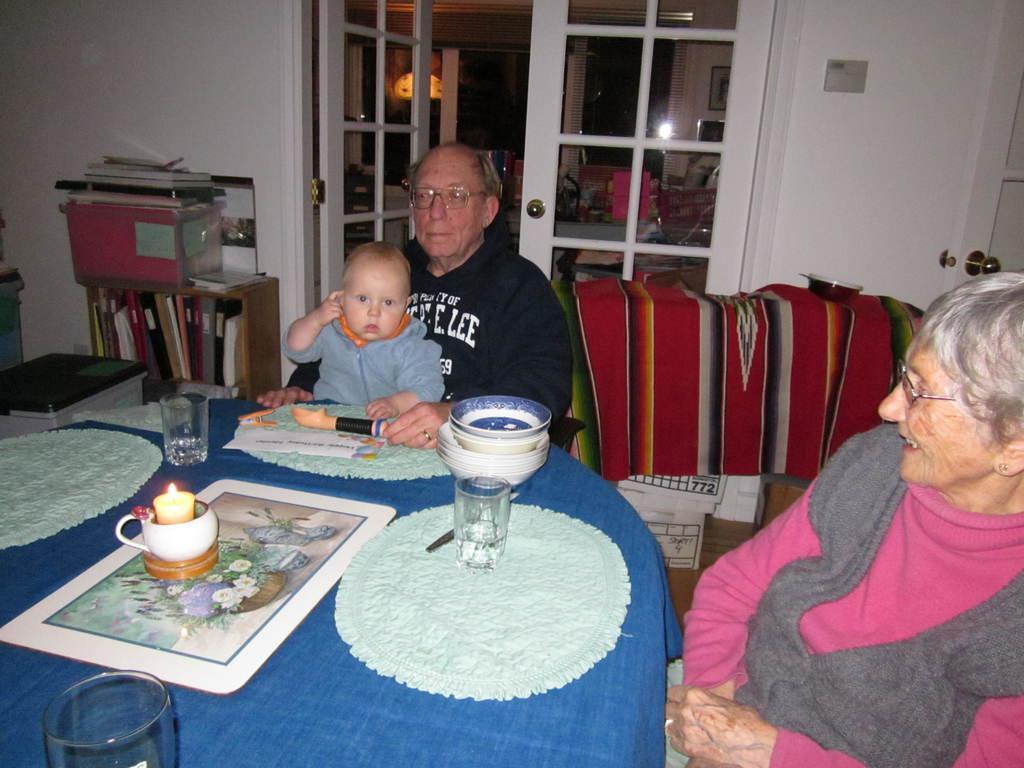How would you summarize this image in a sentence or two? This is a table where bowls, a glass and a candle are kept on it. There is a woman sitting on a chair on the right side and she is smiling. This is a bookshelf. In the background we can see a glass door. 